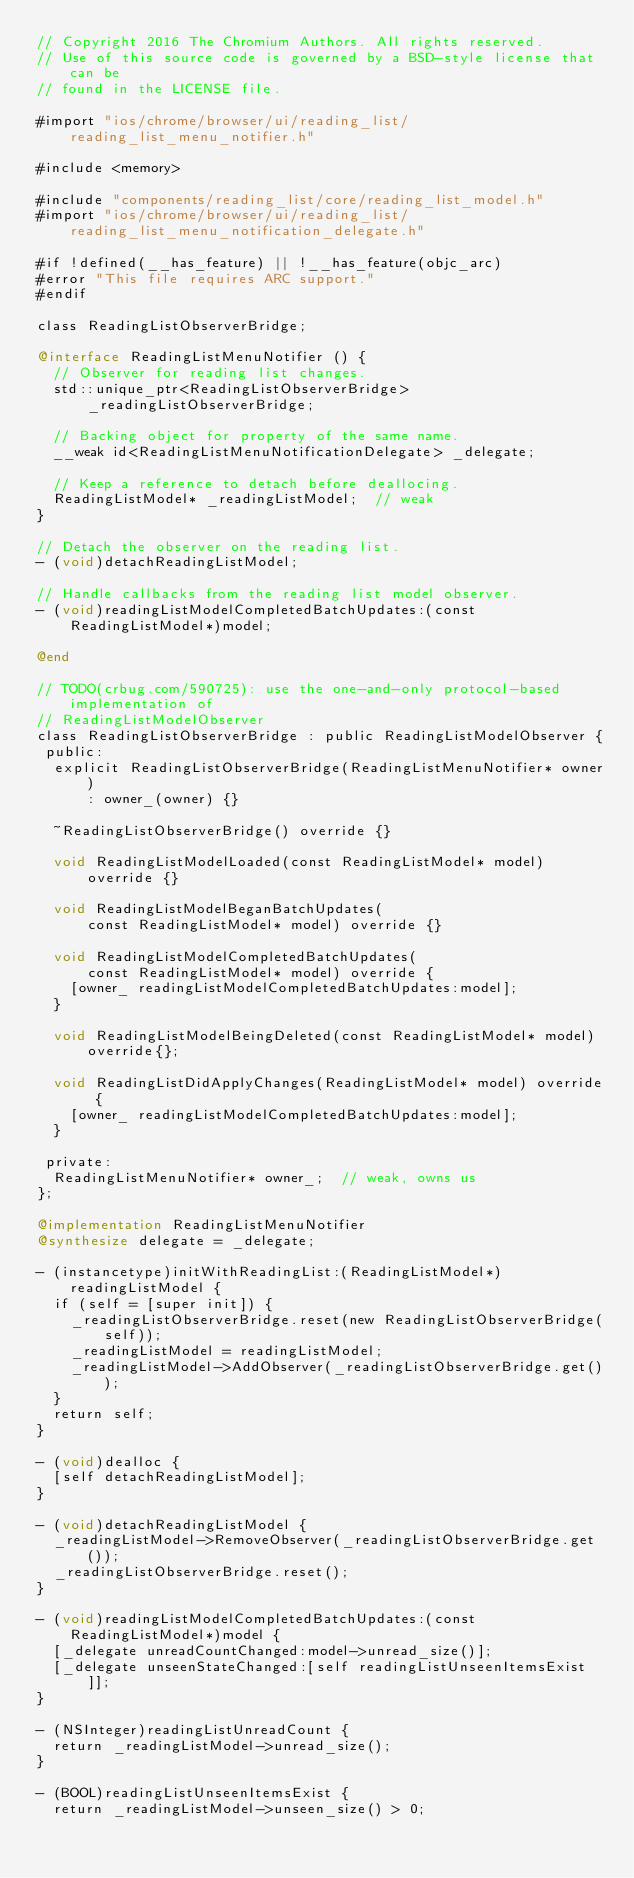Convert code to text. <code><loc_0><loc_0><loc_500><loc_500><_ObjectiveC_>// Copyright 2016 The Chromium Authors. All rights reserved.
// Use of this source code is governed by a BSD-style license that can be
// found in the LICENSE file.

#import "ios/chrome/browser/ui/reading_list/reading_list_menu_notifier.h"

#include <memory>

#include "components/reading_list/core/reading_list_model.h"
#import "ios/chrome/browser/ui/reading_list/reading_list_menu_notification_delegate.h"

#if !defined(__has_feature) || !__has_feature(objc_arc)
#error "This file requires ARC support."
#endif

class ReadingListObserverBridge;

@interface ReadingListMenuNotifier () {
  // Observer for reading list changes.
  std::unique_ptr<ReadingListObserverBridge> _readingListObserverBridge;

  // Backing object for property of the same name.
  __weak id<ReadingListMenuNotificationDelegate> _delegate;

  // Keep a reference to detach before deallocing.
  ReadingListModel* _readingListModel;  // weak
}

// Detach the observer on the reading list.
- (void)detachReadingListModel;

// Handle callbacks from the reading list model observer.
- (void)readingListModelCompletedBatchUpdates:(const ReadingListModel*)model;

@end

// TODO(crbug.com/590725): use the one-and-only protocol-based implementation of
// ReadingListModelObserver
class ReadingListObserverBridge : public ReadingListModelObserver {
 public:
  explicit ReadingListObserverBridge(ReadingListMenuNotifier* owner)
      : owner_(owner) {}

  ~ReadingListObserverBridge() override {}

  void ReadingListModelLoaded(const ReadingListModel* model) override {}

  void ReadingListModelBeganBatchUpdates(
      const ReadingListModel* model) override {}

  void ReadingListModelCompletedBatchUpdates(
      const ReadingListModel* model) override {
    [owner_ readingListModelCompletedBatchUpdates:model];
  }

  void ReadingListModelBeingDeleted(const ReadingListModel* model) override{};

  void ReadingListDidApplyChanges(ReadingListModel* model) override {
    [owner_ readingListModelCompletedBatchUpdates:model];
  }

 private:
  ReadingListMenuNotifier* owner_;  // weak, owns us
};

@implementation ReadingListMenuNotifier
@synthesize delegate = _delegate;

- (instancetype)initWithReadingList:(ReadingListModel*)readingListModel {
  if (self = [super init]) {
    _readingListObserverBridge.reset(new ReadingListObserverBridge(self));
    _readingListModel = readingListModel;
    _readingListModel->AddObserver(_readingListObserverBridge.get());
  }
  return self;
}

- (void)dealloc {
  [self detachReadingListModel];
}

- (void)detachReadingListModel {
  _readingListModel->RemoveObserver(_readingListObserverBridge.get());
  _readingListObserverBridge.reset();
}

- (void)readingListModelCompletedBatchUpdates:(const ReadingListModel*)model {
  [_delegate unreadCountChanged:model->unread_size()];
  [_delegate unseenStateChanged:[self readingListUnseenItemsExist]];
}

- (NSInteger)readingListUnreadCount {
  return _readingListModel->unread_size();
}

- (BOOL)readingListUnseenItemsExist {
  return _readingListModel->unseen_size() > 0;</code> 